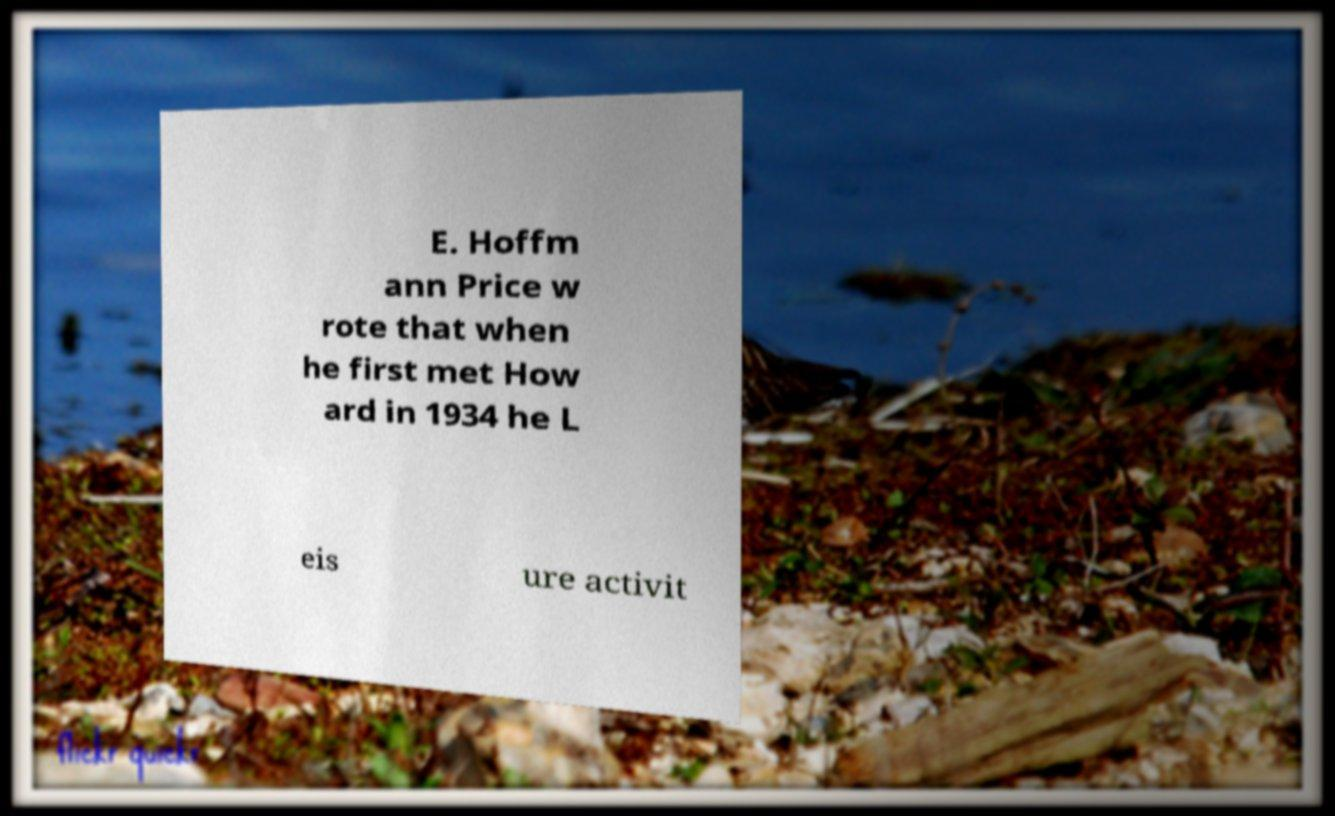Please identify and transcribe the text found in this image. E. Hoffm ann Price w rote that when he first met How ard in 1934 he L eis ure activit 